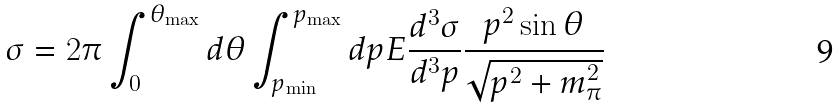Convert formula to latex. <formula><loc_0><loc_0><loc_500><loc_500>\sigma = 2 \pi \int _ { 0 } ^ { \theta _ { \max } } d \theta \int _ { p _ { \min } } ^ { p _ { \max } } d p E \frac { d ^ { 3 } \sigma } { d ^ { 3 } { p } } \frac { p ^ { 2 } \sin \theta } { \sqrt { p ^ { 2 } + m _ { \pi } ^ { 2 } } }</formula> 